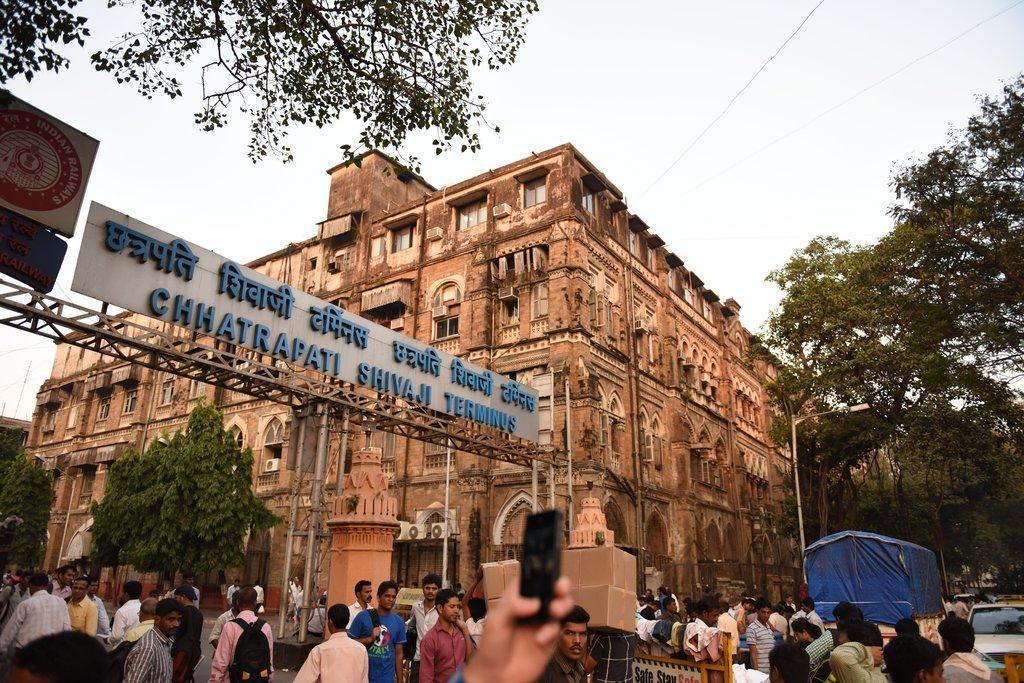Describe this image in one or two sentences. In this image we can see many people are walking on the road, we can see vehicles moving on the road, the person's hand holding the mobile phone, name board, barrier gates, light poles, building, trees and the sky in the background. 